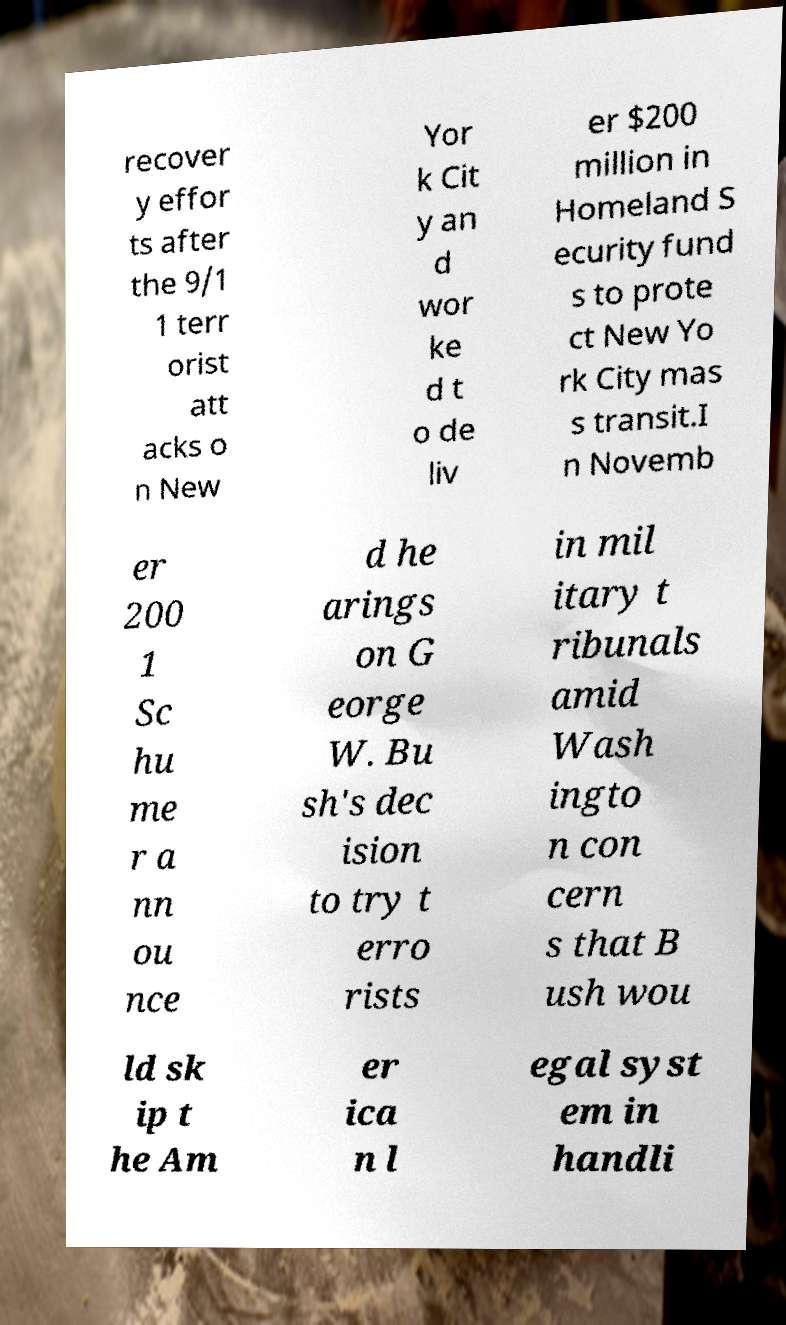Please read and relay the text visible in this image. What does it say? recover y effor ts after the 9/1 1 terr orist att acks o n New Yor k Cit y an d wor ke d t o de liv er $200 million in Homeland S ecurity fund s to prote ct New Yo rk City mas s transit.I n Novemb er 200 1 Sc hu me r a nn ou nce d he arings on G eorge W. Bu sh's dec ision to try t erro rists in mil itary t ribunals amid Wash ingto n con cern s that B ush wou ld sk ip t he Am er ica n l egal syst em in handli 